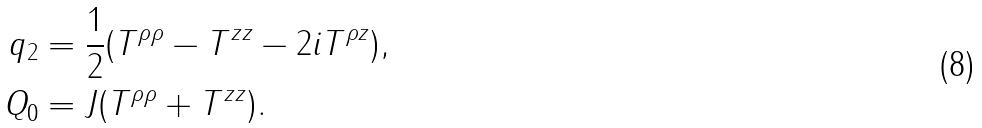Convert formula to latex. <formula><loc_0><loc_0><loc_500><loc_500>q _ { 2 } & = \frac { 1 } { 2 } ( T ^ { \rho \rho } - T ^ { z z } - 2 i T ^ { \rho z } ) , \\ Q _ { 0 } & = J ( T ^ { \rho \rho } + T ^ { z z } ) .</formula> 